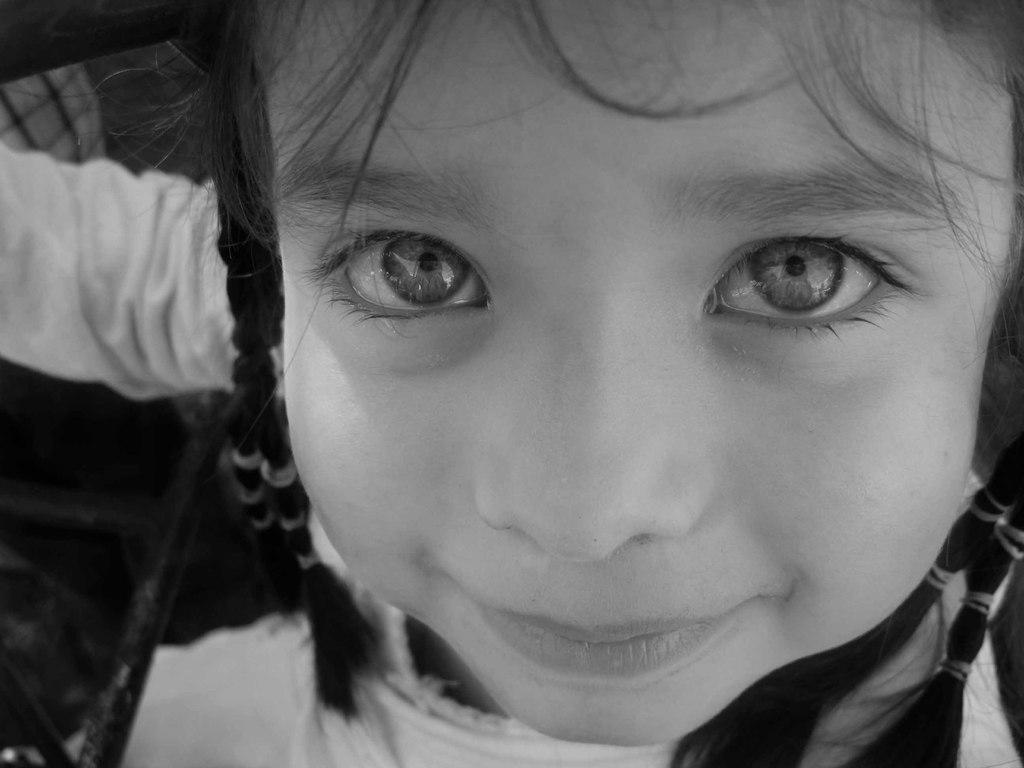Can you describe this image briefly? In the center of the image, we can see a girl. 